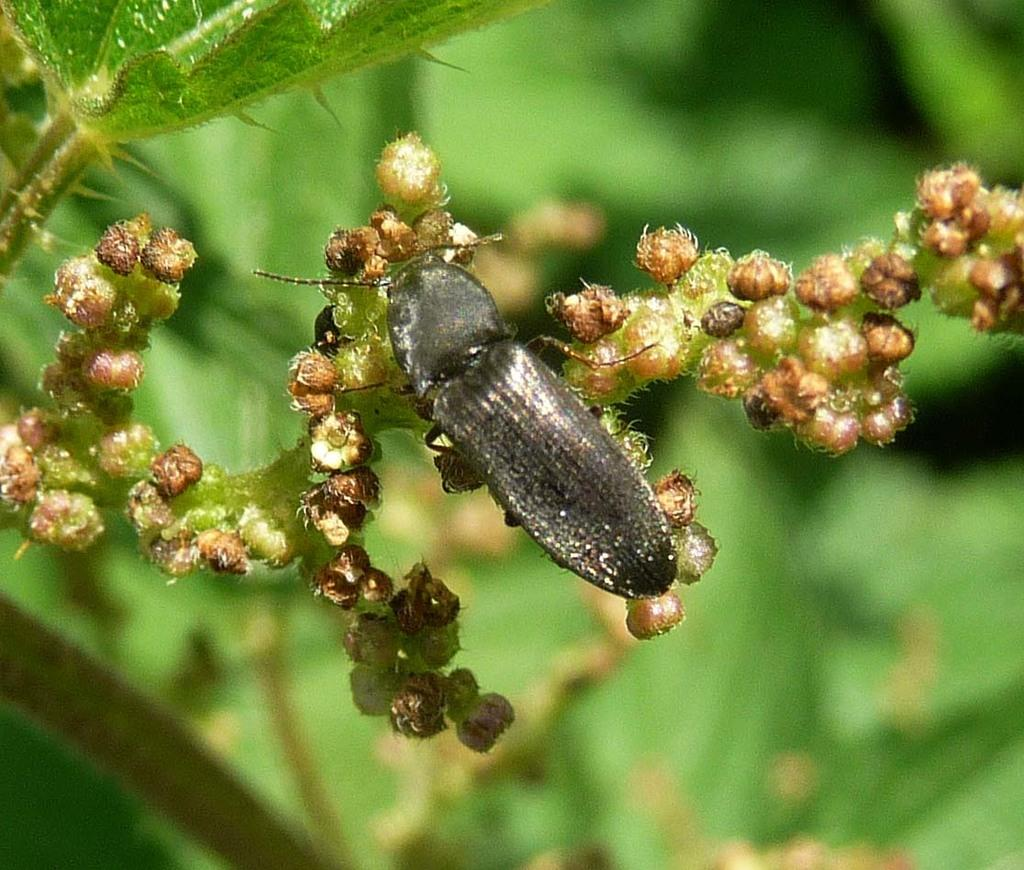What is present on the flower in the image? There is an insect on the flower in the image. What is the color of the background in the image? The background in the image is green. What type of blood can be seen on the insect's knee in the image? There is no blood or knee present on the insect in the image. What advice does the insect's mom give in the image? There is no mom or advice present in the image; it only features an insect on a flower. 